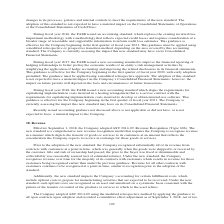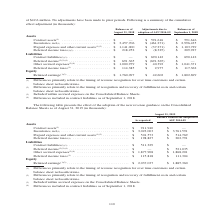According to Jabil Circuit's financial document, What do the differences in contract assets primarily relate to? the timing of revenue recognition for over time customers and certain balance sheet reclassifications.. The document states: "(1) Differences primarily relate to the timing of revenue recognition for over time customers and certain balance sheet reclassifications. (2) Differe..." Also, What were the net inventories as reported? According to the financial document, $3,023,003 (in thousands). The relevant text states: "sets (1) . $ 911,940 $ — Inventories, net (1) . $ 3,023,003 $ 3,761,591 Prepaid expenses and other current assets (1)(2) . $ 501,573 $ 514,769 Deferred income..." Also, What were the contract liabilities as reported? According to the financial document, $511,329 (in thousands). The relevant text states: "2,791 Liabilities Contract liabilities (2)(3) . $ 511,329 $ — Deferred income (2)(3)(4) . $ — $ 521,035 Other accrued expenses (3)(4) . $ 1,877,908 $ 1,868,2..." Also, can you calculate: What was the change in Inventories, net due to adoption of ASU 2014-09? Based on the calculation: 3,023,003-3,761,591, the result is -738588 (in thousands). This is based on the information: "sets (1) . $ 911,940 $ — Inventories, net (1) . $ 3,023,003 $ 3,761,591 Prepaid expenses and other current assets (1)(2) . $ 501,573 $ 514,769 Deferred income 911,940 $ — Inventories, net (1) . $ 3,02..." The key data points involved are: 3,023,003, 3,761,591. Also, can you calculate: What was the change in Prepaid expenses and other current assets due to the adoption of ASU 2014-09? Based on the calculation: 501,573-514,769, the result is -13196 (in thousands). This is based on the information: "ses and other current assets (1)(2) . $ 501,573 $ 514,769 Deferred income taxes (1) . $ 198,827 $ 202,791 Liabilities Contract liabilities (2)(3) . $ 511,329 paid expenses and other current assets (1)..." The key data points involved are: 501,573, 514,769. Also, How many segments as reported exceed $2,000,000 thousand? Counting the relevant items in the document: Inventories, net, Retained earnings, I find 2 instances. The key data points involved are: Inventories, net, Retained earnings. 